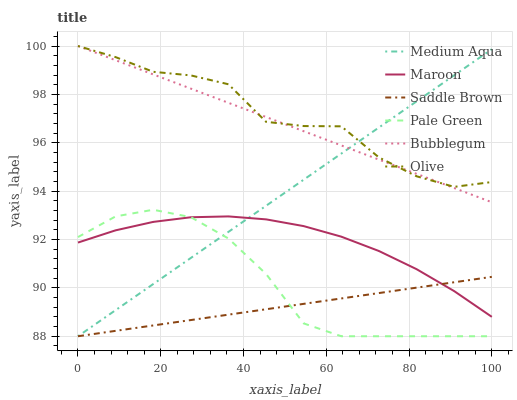Does Saddle Brown have the minimum area under the curve?
Answer yes or no. Yes. Does Olive have the maximum area under the curve?
Answer yes or no. Yes. Does Pale Green have the minimum area under the curve?
Answer yes or no. No. Does Pale Green have the maximum area under the curve?
Answer yes or no. No. Is Medium Aqua the smoothest?
Answer yes or no. Yes. Is Olive the roughest?
Answer yes or no. Yes. Is Pale Green the smoothest?
Answer yes or no. No. Is Pale Green the roughest?
Answer yes or no. No. Does Pale Green have the lowest value?
Answer yes or no. Yes. Does Maroon have the lowest value?
Answer yes or no. No. Does Olive have the highest value?
Answer yes or no. Yes. Does Pale Green have the highest value?
Answer yes or no. No. Is Pale Green less than Olive?
Answer yes or no. Yes. Is Bubblegum greater than Saddle Brown?
Answer yes or no. Yes. Does Saddle Brown intersect Maroon?
Answer yes or no. Yes. Is Saddle Brown less than Maroon?
Answer yes or no. No. Is Saddle Brown greater than Maroon?
Answer yes or no. No. Does Pale Green intersect Olive?
Answer yes or no. No. 